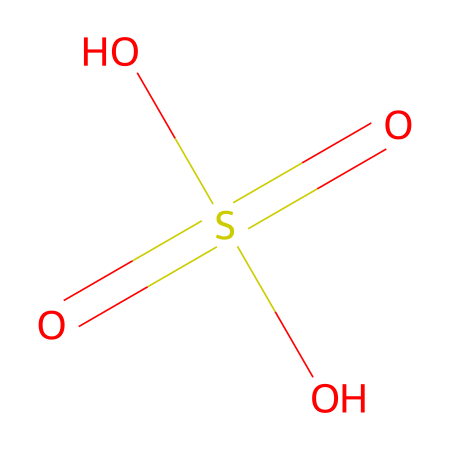What is the name of this chemical? This chemical is represented by the SMILES notation, which corresponds to sulfuric acid, a strong acid commonly used in various industrial processes.
Answer: sulfuric acid How many oxygen atoms are present in this chemical? In the provided structure, there are four total oxygen atoms bonded to the sulfur atom.
Answer: four What type of acid is sulfuric acid classified as? Sulfuric acid is classified as a strong acid because it completely dissociates in water, releasing hydrogen ions.
Answer: strong acid What is the oxidation state of sulfur in sulfuric acid? The oxidation state of sulfur in this chemical can be calculated by considering that it is bonded to four oxygen atoms, leading to an oxidation state of +6.
Answer: +6 Does sulfuric acid contribute to respiratory health issues? Yes, exposure to sulfuric acid can lead to respiratory problems such as irritation, coughing, and bronchial constriction, affecting overall respiratory health.
Answer: yes Is sulfuric acid a primary pollutant? Sulfuric acid can be considered a secondary pollutant formed through atmospheric reactions involving sulfur dioxide; however, it is also emitted directly from certain industrial processes.
Answer: yes What is the relationship between sulfuric acid and acid rain? Sulfuric acid is a major component of acid rain, formed when sulfur dioxide emitted into the atmosphere reacts with water, oxygen, and other chemicals, impacting environmental health.
Answer: major component 